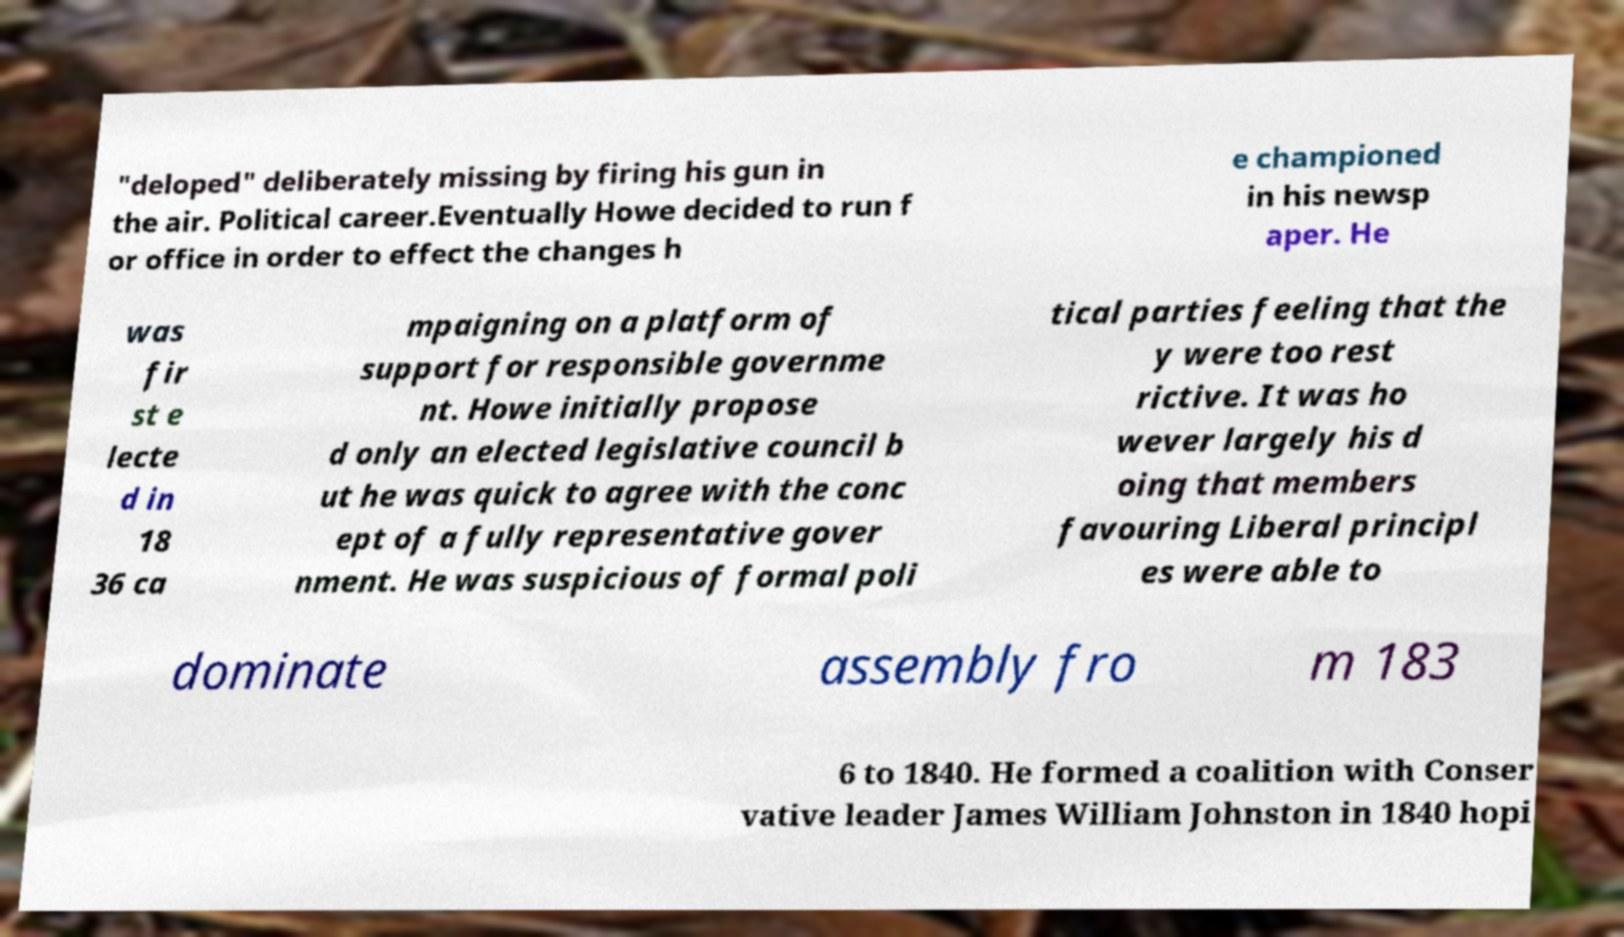There's text embedded in this image that I need extracted. Can you transcribe it verbatim? "deloped" deliberately missing by firing his gun in the air. Political career.Eventually Howe decided to run f or office in order to effect the changes h e championed in his newsp aper. He was fir st e lecte d in 18 36 ca mpaigning on a platform of support for responsible governme nt. Howe initially propose d only an elected legislative council b ut he was quick to agree with the conc ept of a fully representative gover nment. He was suspicious of formal poli tical parties feeling that the y were too rest rictive. It was ho wever largely his d oing that members favouring Liberal principl es were able to dominate assembly fro m 183 6 to 1840. He formed a coalition with Conser vative leader James William Johnston in 1840 hopi 